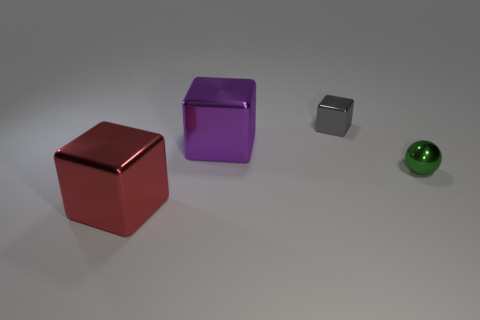Subtract all gray cubes. How many cubes are left? 2 Add 2 large metallic things. How many objects exist? 6 Subtract all purple blocks. How many blocks are left? 2 Subtract all blocks. How many objects are left? 1 Subtract 2 blocks. How many blocks are left? 1 Subtract all blue cubes. Subtract all red balls. How many cubes are left? 3 Subtract all cyan cubes. How many yellow balls are left? 0 Subtract all cyan spheres. Subtract all purple cubes. How many objects are left? 3 Add 4 big purple cubes. How many big purple cubes are left? 5 Add 2 metal things. How many metal things exist? 6 